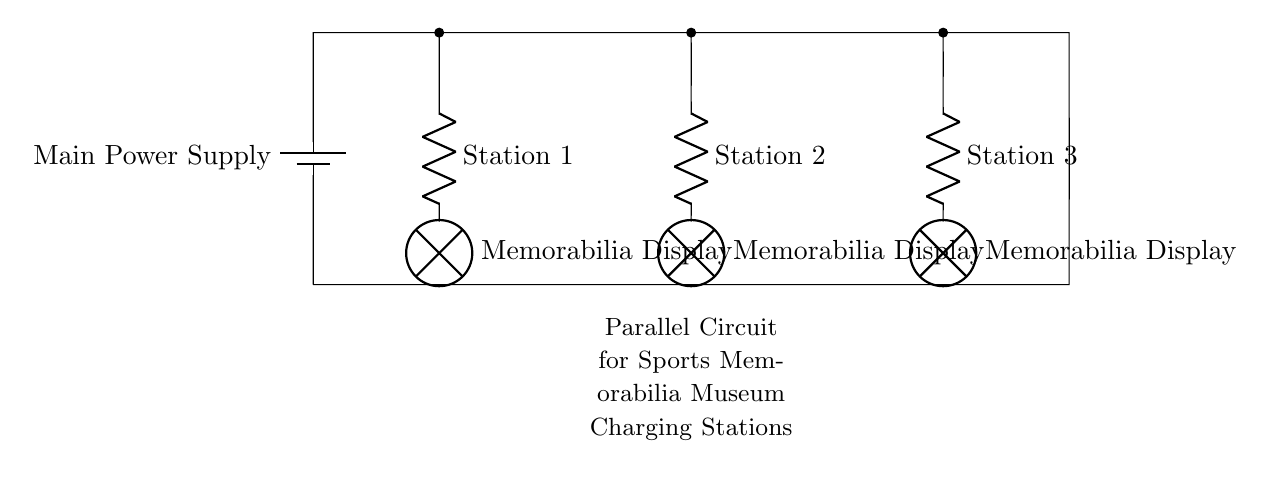What is the main power supply in the circuit? The main power supply is the component providing electrical energy to the circuit, represented by a battery symbol.
Answer: Battery How many charging stations are depicted in the circuit? There are three charging stations, each represented by a resistor symbol connected in parallel to the main power supply.
Answer: Three What is connected to each charging station? Each charging station is connected to a lamp, which represents the memorabilia display that utilizes the charging effect produced by each station.
Answer: Lamp What type of circuit is shown here? The circuit is a parallel circuit because the charging stations are connected across the same voltage source and share the same potential difference.
Answer: Parallel What would happen if one charging station is disconnected? If one charging station is disconnected, the others would continue to function normally, as they are not reliant on one another for current flow, characteristic of parallel circuits.
Answer: Continue functioning What is the purpose of the resistor in each station? The resistor in each station limits the current to the lamp, ensuring safe operation and preventing damage to the memorabilia display.
Answer: Limit current What does the diagram indicate about the voltage across each charging station? The voltage across each charging station is the same as the main power supply because they are in parallel, allowing for equal voltage distribution.
Answer: Same voltage 